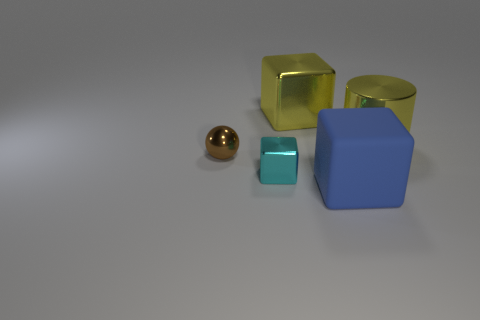How many big blue objects have the same shape as the small cyan thing? Upon examining the image, there is one large blue object which shares the shape of the small cyan object; both are cubes. 